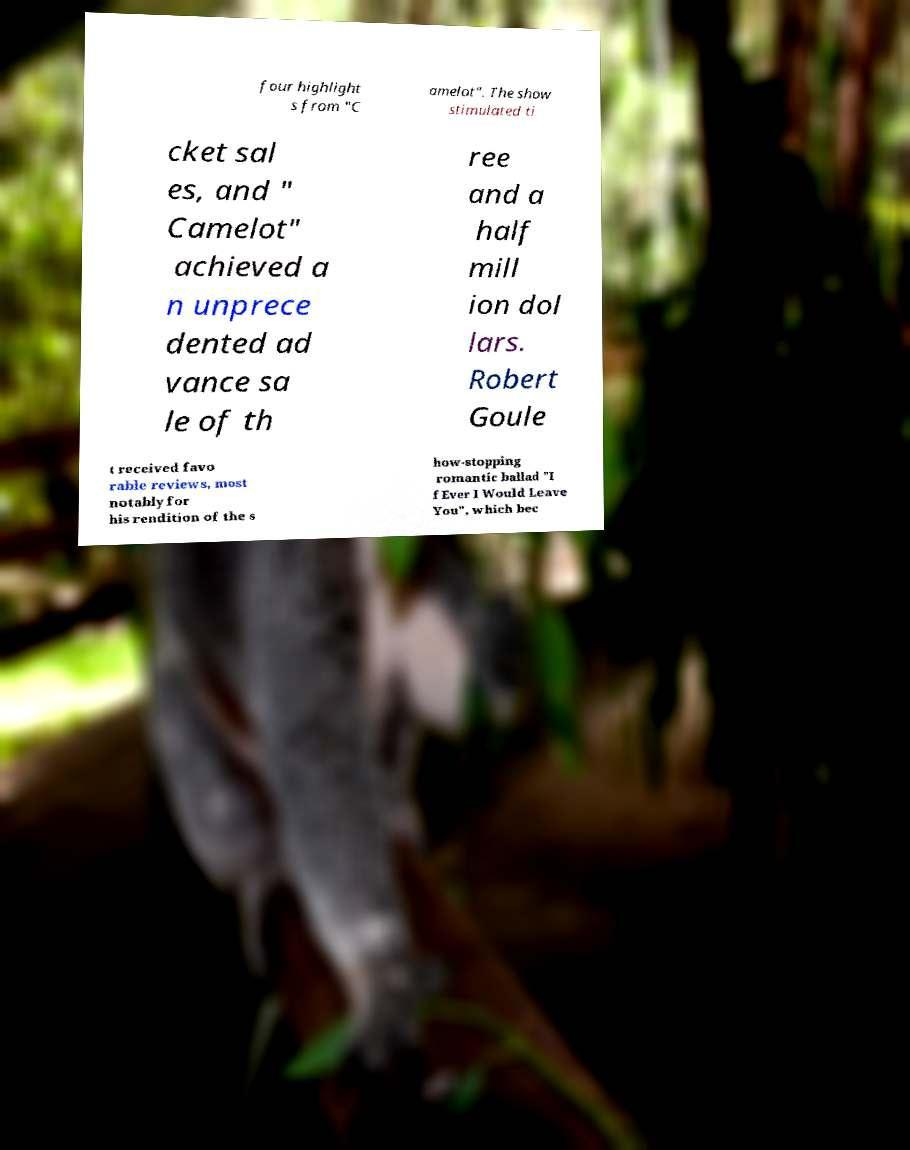Could you assist in decoding the text presented in this image and type it out clearly? four highlight s from "C amelot". The show stimulated ti cket sal es, and " Camelot" achieved a n unprece dented ad vance sa le of th ree and a half mill ion dol lars. Robert Goule t received favo rable reviews, most notably for his rendition of the s how-stopping romantic ballad "I f Ever I Would Leave You", which bec 